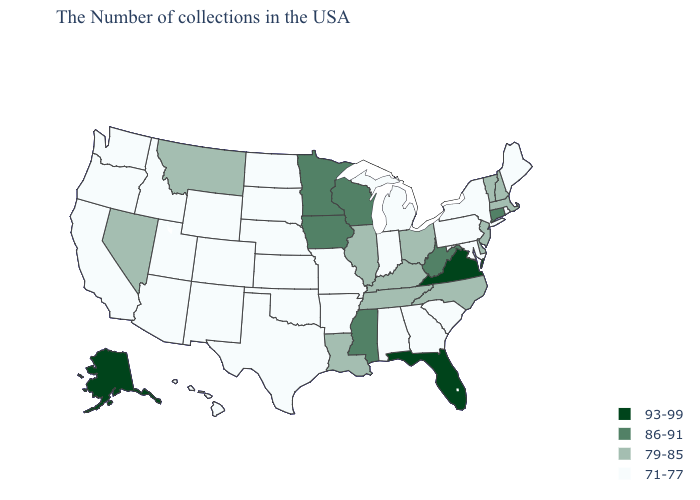Does Maine have a lower value than Florida?
Give a very brief answer. Yes. Does the first symbol in the legend represent the smallest category?
Keep it brief. No. Which states hav the highest value in the South?
Short answer required. Virginia, Florida. What is the value of Kansas?
Keep it brief. 71-77. What is the highest value in the South ?
Give a very brief answer. 93-99. Does Florida have the highest value in the South?
Give a very brief answer. Yes. Does Oregon have the same value as New Jersey?
Keep it brief. No. What is the lowest value in states that border Illinois?
Be succinct. 71-77. Which states have the lowest value in the South?
Concise answer only. Maryland, South Carolina, Georgia, Alabama, Arkansas, Oklahoma, Texas. What is the highest value in the MidWest ?
Be succinct. 86-91. Does Wyoming have the same value as Massachusetts?
Write a very short answer. No. Does New Jersey have the lowest value in the Northeast?
Be succinct. No. Name the states that have a value in the range 79-85?
Quick response, please. Massachusetts, New Hampshire, Vermont, New Jersey, Delaware, North Carolina, Ohio, Kentucky, Tennessee, Illinois, Louisiana, Montana, Nevada. What is the value of Minnesota?
Be succinct. 86-91. 